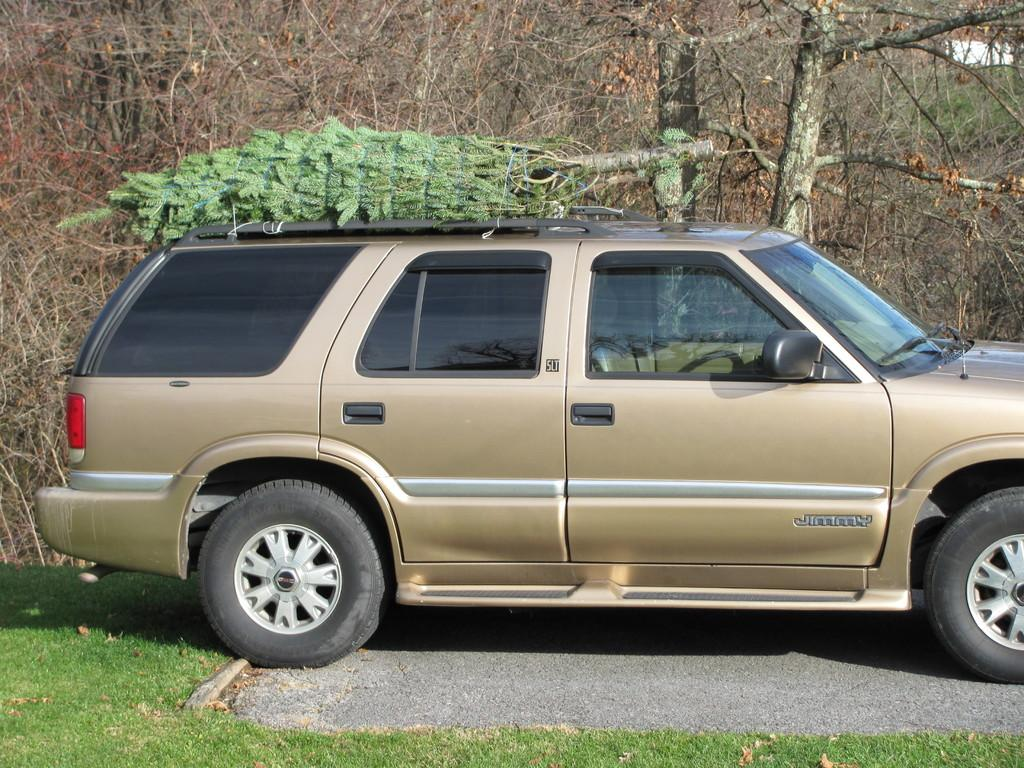What is the main subject in the center of the image? There is a car in the center of the image. What can be seen in the background of the image? There are trees in the background of the image. What type of vegetation is at the bottom of the image? There is grass at the bottom of the image. What is the car driving on in the image? There is a road in the image. What type of scarf is the maid wearing in the image? There is no maid or scarf present in the image. 